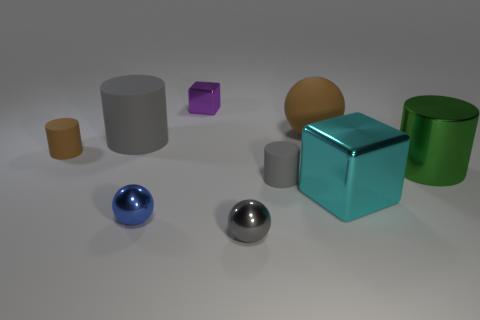Subtract all metal spheres. How many spheres are left? 1 Subtract all green cubes. How many gray cylinders are left? 2 Subtract all brown cylinders. How many cylinders are left? 3 Subtract all red balls. Subtract all green cubes. How many balls are left? 3 Add 1 green rubber cylinders. How many objects exist? 10 Subtract all cubes. How many objects are left? 7 Add 1 gray metal balls. How many gray metal balls exist? 2 Subtract 0 purple spheres. How many objects are left? 9 Subtract all large matte spheres. Subtract all small brown rubber things. How many objects are left? 7 Add 2 large metallic cylinders. How many large metallic cylinders are left? 3 